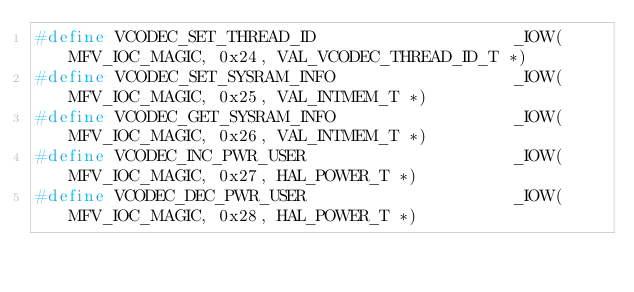Convert code to text. <code><loc_0><loc_0><loc_500><loc_500><_C_>#define VCODEC_SET_THREAD_ID                    _IOW(MFV_IOC_MAGIC, 0x24, VAL_VCODEC_THREAD_ID_T *)
#define VCODEC_SET_SYSRAM_INFO                  _IOW(MFV_IOC_MAGIC, 0x25, VAL_INTMEM_T *)
#define VCODEC_GET_SYSRAM_INFO                  _IOW(MFV_IOC_MAGIC, 0x26, VAL_INTMEM_T *)
#define VCODEC_INC_PWR_USER                     _IOW(MFV_IOC_MAGIC, 0x27, HAL_POWER_T *)
#define VCODEC_DEC_PWR_USER                     _IOW(MFV_IOC_MAGIC, 0x28, HAL_POWER_T *)</code> 